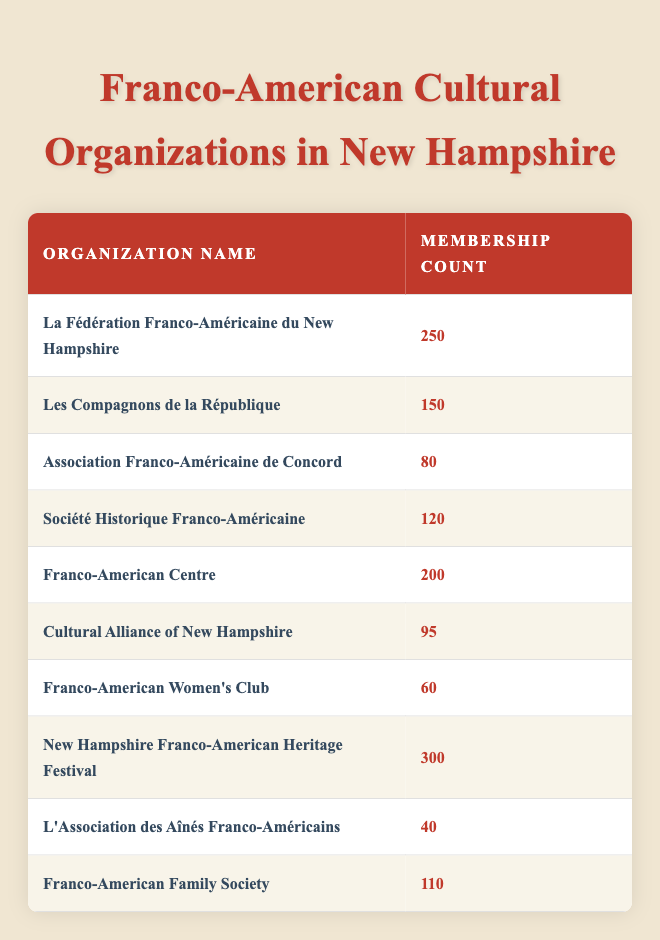What is the organization with the highest membership count? By examining the table, we see the membership counts listed beside each organization's name. The highest number is 300, associated with "New Hampshire Franco-American Heritage Festival."
Answer: New Hampshire Franco-American Heritage Festival How many members does La Fédération Franco-Américaine du New Hampshire have? The table directly lists the membership count for "La Fédération Franco-Américaine du New Hampshire" as 250.
Answer: 250 What is the total membership of all organizations listed in the table? We sum the membership counts: 250 + 150 + 80 + 120 + 200 + 95 + 60 + 300 + 40 + 110 = 1,405.
Answer: 1,405 Is the Franco-American Women's Club among the organizations with over 100 members? Checking the membership count for "Franco-American Women's Club," which is 60, it's clear that it is below 100. Thus, it is not among those organizations.
Answer: No How many organizations have a membership count that is less than 100? Analyzing the table lists two organizations below 100: "Franco-American Women's Club" (60) and "L'Association des Aînés Franco-Américains" (40). Hence, there are two organizations.
Answer: 2 What is the average membership count among all organizations? First, we sum the membership counts as calculated earlier (1,405) and then divide by the total number of organizations, which is 10: 1,405 / 10 = 140.5.
Answer: 140.5 Which organization has the lowest membership count? The table shows "L'Association des Aînés Franco-Américains" with a membership count of 40, making it the lowest among all listed.
Answer: L'Association des Aînés Franco-Américains Are there any organizations with a membership count of exactly 100? Checking the table, we find that none of the organizations have a membership count of exactly 100, so the answer is no.
Answer: No What percentage of total membership does the New Hampshire Franco-American Heritage Festival represent? The membership count for this festival is 300. To find the percentage, we calculate (300 / 1,405) * 100, which equals approximately 21.34%.
Answer: 21.34% 